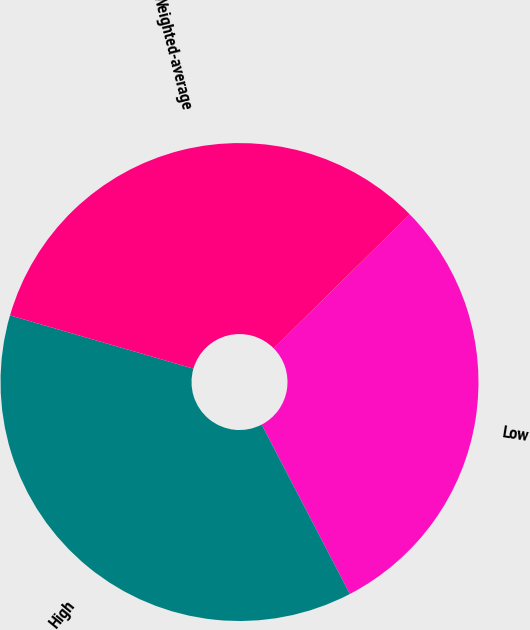Convert chart. <chart><loc_0><loc_0><loc_500><loc_500><pie_chart><fcel>Low<fcel>High<fcel>Weighted-average<nl><fcel>29.74%<fcel>37.14%<fcel>33.12%<nl></chart> 